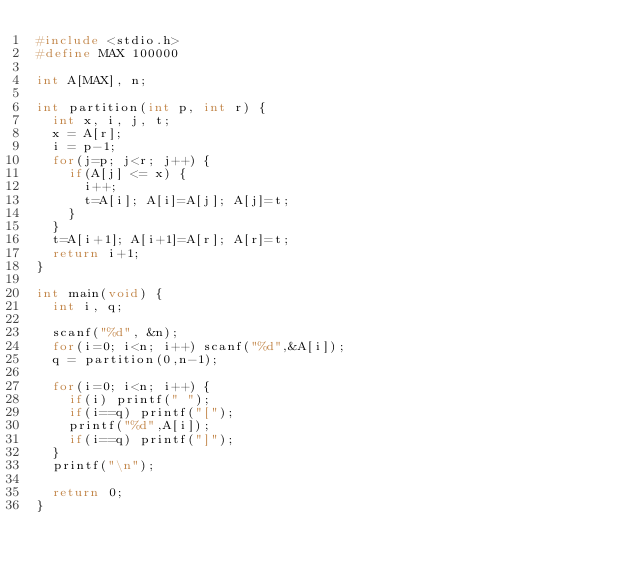<code> <loc_0><loc_0><loc_500><loc_500><_C_>#include <stdio.h>
#define MAX 100000

int A[MAX], n;

int partition(int p, int r) {
  int x, i, j, t;
  x = A[r];
  i = p-1;
  for(j=p; j<r; j++) {
    if(A[j] <= x) {
      i++;
      t=A[i]; A[i]=A[j]; A[j]=t;
    }
  }
  t=A[i+1]; A[i+1]=A[r]; A[r]=t;
  return i+1;
}

int main(void) {
  int i, q;

  scanf("%d", &n);
  for(i=0; i<n; i++) scanf("%d",&A[i]);
  q = partition(0,n-1);

  for(i=0; i<n; i++) {
    if(i) printf(" ");
    if(i==q) printf("[");
    printf("%d",A[i]);
    if(i==q) printf("]");
  }
  printf("\n");

  return 0;
}
</code> 